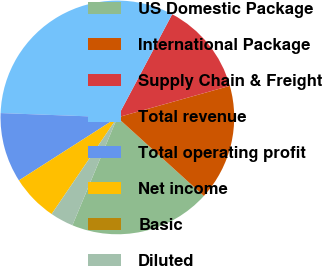Convert chart. <chart><loc_0><loc_0><loc_500><loc_500><pie_chart><fcel>US Domestic Package<fcel>International Package<fcel>Supply Chain & Freight<fcel>Total revenue<fcel>Total operating profit<fcel>Net income<fcel>Basic<fcel>Diluted<nl><fcel>19.55%<fcel>16.09%<fcel>12.87%<fcel>32.18%<fcel>9.65%<fcel>6.44%<fcel>0.0%<fcel>3.22%<nl></chart> 